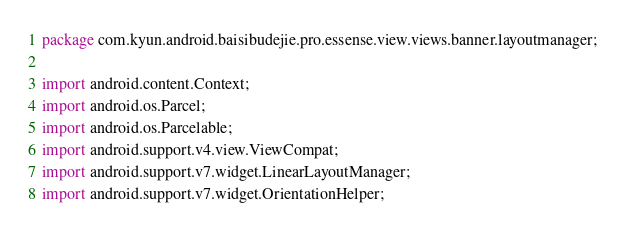<code> <loc_0><loc_0><loc_500><loc_500><_Java_>package com.kyun.android.baisibudejie.pro.essense.view.views.banner.layoutmanager;

import android.content.Context;
import android.os.Parcel;
import android.os.Parcelable;
import android.support.v4.view.ViewCompat;
import android.support.v7.widget.LinearLayoutManager;
import android.support.v7.widget.OrientationHelper;</code> 